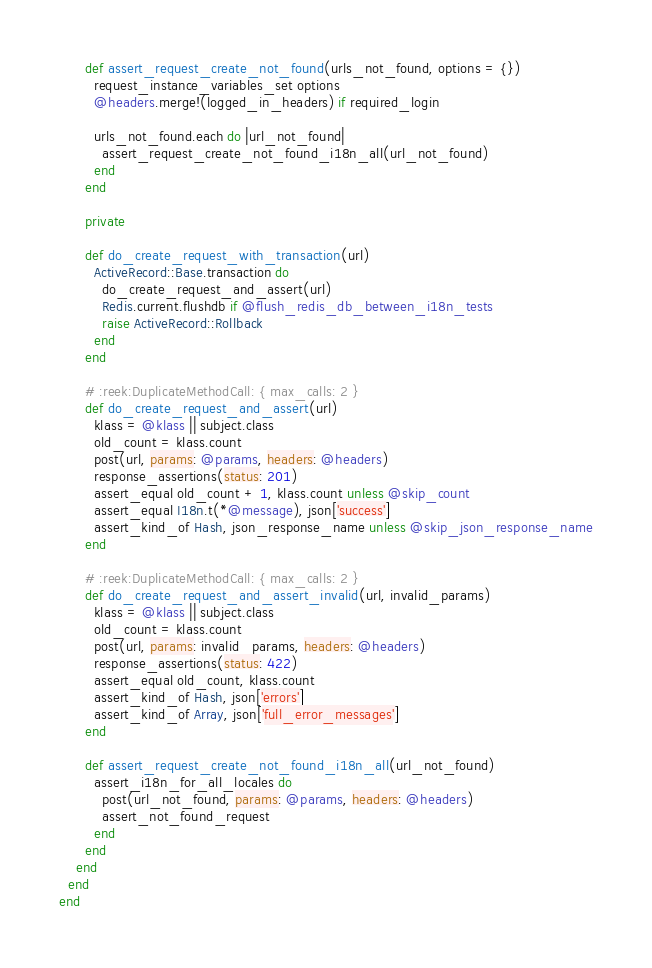Convert code to text. <code><loc_0><loc_0><loc_500><loc_500><_Ruby_>      def assert_request_create_not_found(urls_not_found, options = {})
        request_instance_variables_set options
        @headers.merge!(logged_in_headers) if required_login

        urls_not_found.each do |url_not_found|
          assert_request_create_not_found_i18n_all(url_not_found)
        end
      end

      private

      def do_create_request_with_transaction(url)
        ActiveRecord::Base.transaction do
          do_create_request_and_assert(url)
          Redis.current.flushdb if @flush_redis_db_between_i18n_tests
          raise ActiveRecord::Rollback
        end
      end

      # :reek:DuplicateMethodCall: { max_calls: 2 }
      def do_create_request_and_assert(url)
        klass = @klass || subject.class
        old_count = klass.count
        post(url, params: @params, headers: @headers)
        response_assertions(status: 201)
        assert_equal old_count + 1, klass.count unless @skip_count
        assert_equal I18n.t(*@message), json['success']
        assert_kind_of Hash, json_response_name unless @skip_json_response_name
      end

      # :reek:DuplicateMethodCall: { max_calls: 2 }
      def do_create_request_and_assert_invalid(url, invalid_params)
        klass = @klass || subject.class
        old_count = klass.count
        post(url, params: invalid_params, headers: @headers)
        response_assertions(status: 422)
        assert_equal old_count, klass.count
        assert_kind_of Hash, json['errors']
        assert_kind_of Array, json['full_error_messages']
      end

      def assert_request_create_not_found_i18n_all(url_not_found)
        assert_i18n_for_all_locales do
          post(url_not_found, params: @params, headers: @headers)
          assert_not_found_request
        end
      end
    end
  end
end
</code> 